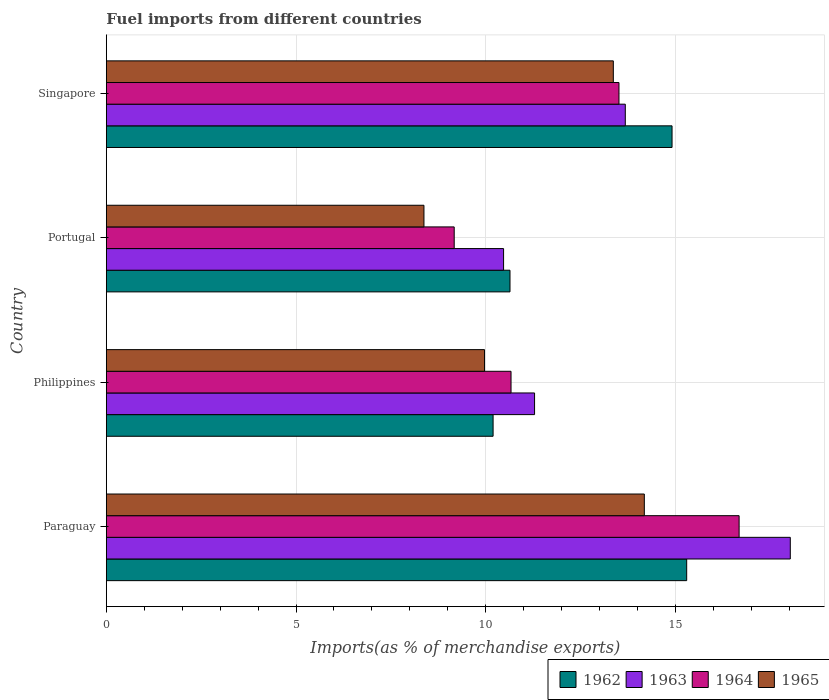How many groups of bars are there?
Provide a short and direct response. 4. Are the number of bars on each tick of the Y-axis equal?
Ensure brevity in your answer.  Yes. How many bars are there on the 1st tick from the bottom?
Keep it short and to the point. 4. What is the label of the 3rd group of bars from the top?
Provide a succinct answer. Philippines. In how many cases, is the number of bars for a given country not equal to the number of legend labels?
Your response must be concise. 0. What is the percentage of imports to different countries in 1962 in Philippines?
Your response must be concise. 10.2. Across all countries, what is the maximum percentage of imports to different countries in 1964?
Provide a succinct answer. 16.68. Across all countries, what is the minimum percentage of imports to different countries in 1965?
Offer a very short reply. 8.37. In which country was the percentage of imports to different countries in 1965 maximum?
Your response must be concise. Paraguay. In which country was the percentage of imports to different countries in 1964 minimum?
Your answer should be compact. Portugal. What is the total percentage of imports to different countries in 1962 in the graph?
Your response must be concise. 51.05. What is the difference between the percentage of imports to different countries in 1964 in Philippines and that in Singapore?
Provide a short and direct response. -2.85. What is the difference between the percentage of imports to different countries in 1963 in Portugal and the percentage of imports to different countries in 1965 in Paraguay?
Offer a very short reply. -3.71. What is the average percentage of imports to different countries in 1963 per country?
Keep it short and to the point. 13.37. What is the difference between the percentage of imports to different countries in 1962 and percentage of imports to different countries in 1965 in Portugal?
Your response must be concise. 2.27. What is the ratio of the percentage of imports to different countries in 1963 in Paraguay to that in Philippines?
Make the answer very short. 1.6. Is the percentage of imports to different countries in 1963 in Paraguay less than that in Philippines?
Ensure brevity in your answer.  No. What is the difference between the highest and the second highest percentage of imports to different countries in 1964?
Make the answer very short. 3.17. What is the difference between the highest and the lowest percentage of imports to different countries in 1963?
Offer a very short reply. 7.56. What does the 4th bar from the top in Philippines represents?
Offer a very short reply. 1962. What does the 4th bar from the bottom in Philippines represents?
Make the answer very short. 1965. Are all the bars in the graph horizontal?
Keep it short and to the point. Yes. Does the graph contain grids?
Make the answer very short. Yes. Where does the legend appear in the graph?
Your answer should be very brief. Bottom right. How many legend labels are there?
Your answer should be compact. 4. What is the title of the graph?
Offer a terse response. Fuel imports from different countries. Does "2006" appear as one of the legend labels in the graph?
Ensure brevity in your answer.  No. What is the label or title of the X-axis?
Your answer should be very brief. Imports(as % of merchandise exports). What is the label or title of the Y-axis?
Your answer should be very brief. Country. What is the Imports(as % of merchandise exports) of 1962 in Paraguay?
Your answer should be very brief. 15.3. What is the Imports(as % of merchandise exports) in 1963 in Paraguay?
Give a very brief answer. 18.03. What is the Imports(as % of merchandise exports) in 1964 in Paraguay?
Provide a succinct answer. 16.68. What is the Imports(as % of merchandise exports) of 1965 in Paraguay?
Your response must be concise. 14.18. What is the Imports(as % of merchandise exports) in 1962 in Philippines?
Your answer should be compact. 10.2. What is the Imports(as % of merchandise exports) of 1963 in Philippines?
Ensure brevity in your answer.  11.29. What is the Imports(as % of merchandise exports) in 1964 in Philippines?
Provide a succinct answer. 10.67. What is the Imports(as % of merchandise exports) of 1965 in Philippines?
Provide a succinct answer. 9.97. What is the Imports(as % of merchandise exports) in 1962 in Portugal?
Keep it short and to the point. 10.64. What is the Imports(as % of merchandise exports) in 1963 in Portugal?
Offer a terse response. 10.47. What is the Imports(as % of merchandise exports) of 1964 in Portugal?
Your answer should be very brief. 9.17. What is the Imports(as % of merchandise exports) of 1965 in Portugal?
Provide a succinct answer. 8.37. What is the Imports(as % of merchandise exports) of 1962 in Singapore?
Keep it short and to the point. 14.91. What is the Imports(as % of merchandise exports) in 1963 in Singapore?
Offer a very short reply. 13.68. What is the Imports(as % of merchandise exports) of 1964 in Singapore?
Offer a terse response. 13.51. What is the Imports(as % of merchandise exports) in 1965 in Singapore?
Offer a terse response. 13.37. Across all countries, what is the maximum Imports(as % of merchandise exports) of 1962?
Your answer should be very brief. 15.3. Across all countries, what is the maximum Imports(as % of merchandise exports) of 1963?
Ensure brevity in your answer.  18.03. Across all countries, what is the maximum Imports(as % of merchandise exports) in 1964?
Your answer should be very brief. 16.68. Across all countries, what is the maximum Imports(as % of merchandise exports) of 1965?
Your answer should be very brief. 14.18. Across all countries, what is the minimum Imports(as % of merchandise exports) in 1962?
Offer a very short reply. 10.2. Across all countries, what is the minimum Imports(as % of merchandise exports) in 1963?
Your response must be concise. 10.47. Across all countries, what is the minimum Imports(as % of merchandise exports) in 1964?
Provide a short and direct response. 9.17. Across all countries, what is the minimum Imports(as % of merchandise exports) of 1965?
Offer a terse response. 8.37. What is the total Imports(as % of merchandise exports) in 1962 in the graph?
Make the answer very short. 51.05. What is the total Imports(as % of merchandise exports) in 1963 in the graph?
Offer a very short reply. 53.47. What is the total Imports(as % of merchandise exports) in 1964 in the graph?
Offer a terse response. 50.03. What is the total Imports(as % of merchandise exports) of 1965 in the graph?
Your answer should be compact. 45.89. What is the difference between the Imports(as % of merchandise exports) in 1962 in Paraguay and that in Philippines?
Offer a terse response. 5.1. What is the difference between the Imports(as % of merchandise exports) in 1963 in Paraguay and that in Philippines?
Make the answer very short. 6.74. What is the difference between the Imports(as % of merchandise exports) of 1964 in Paraguay and that in Philippines?
Ensure brevity in your answer.  6.01. What is the difference between the Imports(as % of merchandise exports) of 1965 in Paraguay and that in Philippines?
Provide a short and direct response. 4.21. What is the difference between the Imports(as % of merchandise exports) of 1962 in Paraguay and that in Portugal?
Offer a very short reply. 4.66. What is the difference between the Imports(as % of merchandise exports) of 1963 in Paraguay and that in Portugal?
Keep it short and to the point. 7.56. What is the difference between the Imports(as % of merchandise exports) of 1964 in Paraguay and that in Portugal?
Offer a terse response. 7.51. What is the difference between the Imports(as % of merchandise exports) of 1965 in Paraguay and that in Portugal?
Provide a succinct answer. 5.81. What is the difference between the Imports(as % of merchandise exports) of 1962 in Paraguay and that in Singapore?
Your answer should be compact. 0.39. What is the difference between the Imports(as % of merchandise exports) in 1963 in Paraguay and that in Singapore?
Keep it short and to the point. 4.35. What is the difference between the Imports(as % of merchandise exports) in 1964 in Paraguay and that in Singapore?
Provide a succinct answer. 3.17. What is the difference between the Imports(as % of merchandise exports) in 1965 in Paraguay and that in Singapore?
Ensure brevity in your answer.  0.82. What is the difference between the Imports(as % of merchandise exports) in 1962 in Philippines and that in Portugal?
Keep it short and to the point. -0.45. What is the difference between the Imports(as % of merchandise exports) of 1963 in Philippines and that in Portugal?
Provide a short and direct response. 0.82. What is the difference between the Imports(as % of merchandise exports) of 1964 in Philippines and that in Portugal?
Offer a very short reply. 1.5. What is the difference between the Imports(as % of merchandise exports) of 1965 in Philippines and that in Portugal?
Ensure brevity in your answer.  1.6. What is the difference between the Imports(as % of merchandise exports) in 1962 in Philippines and that in Singapore?
Your answer should be very brief. -4.72. What is the difference between the Imports(as % of merchandise exports) of 1963 in Philippines and that in Singapore?
Your answer should be compact. -2.39. What is the difference between the Imports(as % of merchandise exports) of 1964 in Philippines and that in Singapore?
Make the answer very short. -2.85. What is the difference between the Imports(as % of merchandise exports) of 1965 in Philippines and that in Singapore?
Offer a very short reply. -3.4. What is the difference between the Imports(as % of merchandise exports) of 1962 in Portugal and that in Singapore?
Your answer should be compact. -4.27. What is the difference between the Imports(as % of merchandise exports) of 1963 in Portugal and that in Singapore?
Your response must be concise. -3.21. What is the difference between the Imports(as % of merchandise exports) of 1964 in Portugal and that in Singapore?
Your answer should be very brief. -4.34. What is the difference between the Imports(as % of merchandise exports) in 1965 in Portugal and that in Singapore?
Provide a short and direct response. -4.99. What is the difference between the Imports(as % of merchandise exports) of 1962 in Paraguay and the Imports(as % of merchandise exports) of 1963 in Philippines?
Your response must be concise. 4.01. What is the difference between the Imports(as % of merchandise exports) of 1962 in Paraguay and the Imports(as % of merchandise exports) of 1964 in Philippines?
Keep it short and to the point. 4.63. What is the difference between the Imports(as % of merchandise exports) in 1962 in Paraguay and the Imports(as % of merchandise exports) in 1965 in Philippines?
Your answer should be very brief. 5.33. What is the difference between the Imports(as % of merchandise exports) of 1963 in Paraguay and the Imports(as % of merchandise exports) of 1964 in Philippines?
Your answer should be compact. 7.36. What is the difference between the Imports(as % of merchandise exports) in 1963 in Paraguay and the Imports(as % of merchandise exports) in 1965 in Philippines?
Ensure brevity in your answer.  8.06. What is the difference between the Imports(as % of merchandise exports) in 1964 in Paraguay and the Imports(as % of merchandise exports) in 1965 in Philippines?
Provide a short and direct response. 6.71. What is the difference between the Imports(as % of merchandise exports) of 1962 in Paraguay and the Imports(as % of merchandise exports) of 1963 in Portugal?
Offer a very short reply. 4.83. What is the difference between the Imports(as % of merchandise exports) of 1962 in Paraguay and the Imports(as % of merchandise exports) of 1964 in Portugal?
Offer a very short reply. 6.13. What is the difference between the Imports(as % of merchandise exports) of 1962 in Paraguay and the Imports(as % of merchandise exports) of 1965 in Portugal?
Offer a terse response. 6.93. What is the difference between the Imports(as % of merchandise exports) of 1963 in Paraguay and the Imports(as % of merchandise exports) of 1964 in Portugal?
Your answer should be compact. 8.86. What is the difference between the Imports(as % of merchandise exports) in 1963 in Paraguay and the Imports(as % of merchandise exports) in 1965 in Portugal?
Ensure brevity in your answer.  9.66. What is the difference between the Imports(as % of merchandise exports) in 1964 in Paraguay and the Imports(as % of merchandise exports) in 1965 in Portugal?
Provide a succinct answer. 8.31. What is the difference between the Imports(as % of merchandise exports) of 1962 in Paraguay and the Imports(as % of merchandise exports) of 1963 in Singapore?
Give a very brief answer. 1.62. What is the difference between the Imports(as % of merchandise exports) in 1962 in Paraguay and the Imports(as % of merchandise exports) in 1964 in Singapore?
Ensure brevity in your answer.  1.79. What is the difference between the Imports(as % of merchandise exports) of 1962 in Paraguay and the Imports(as % of merchandise exports) of 1965 in Singapore?
Give a very brief answer. 1.93. What is the difference between the Imports(as % of merchandise exports) in 1963 in Paraguay and the Imports(as % of merchandise exports) in 1964 in Singapore?
Provide a succinct answer. 4.52. What is the difference between the Imports(as % of merchandise exports) in 1963 in Paraguay and the Imports(as % of merchandise exports) in 1965 in Singapore?
Provide a short and direct response. 4.67. What is the difference between the Imports(as % of merchandise exports) in 1964 in Paraguay and the Imports(as % of merchandise exports) in 1965 in Singapore?
Your answer should be very brief. 3.32. What is the difference between the Imports(as % of merchandise exports) in 1962 in Philippines and the Imports(as % of merchandise exports) in 1963 in Portugal?
Your response must be concise. -0.28. What is the difference between the Imports(as % of merchandise exports) of 1962 in Philippines and the Imports(as % of merchandise exports) of 1964 in Portugal?
Give a very brief answer. 1.03. What is the difference between the Imports(as % of merchandise exports) in 1962 in Philippines and the Imports(as % of merchandise exports) in 1965 in Portugal?
Ensure brevity in your answer.  1.82. What is the difference between the Imports(as % of merchandise exports) of 1963 in Philippines and the Imports(as % of merchandise exports) of 1964 in Portugal?
Offer a terse response. 2.12. What is the difference between the Imports(as % of merchandise exports) of 1963 in Philippines and the Imports(as % of merchandise exports) of 1965 in Portugal?
Offer a terse response. 2.92. What is the difference between the Imports(as % of merchandise exports) of 1964 in Philippines and the Imports(as % of merchandise exports) of 1965 in Portugal?
Keep it short and to the point. 2.3. What is the difference between the Imports(as % of merchandise exports) of 1962 in Philippines and the Imports(as % of merchandise exports) of 1963 in Singapore?
Offer a very short reply. -3.49. What is the difference between the Imports(as % of merchandise exports) in 1962 in Philippines and the Imports(as % of merchandise exports) in 1964 in Singapore?
Ensure brevity in your answer.  -3.32. What is the difference between the Imports(as % of merchandise exports) in 1962 in Philippines and the Imports(as % of merchandise exports) in 1965 in Singapore?
Provide a succinct answer. -3.17. What is the difference between the Imports(as % of merchandise exports) of 1963 in Philippines and the Imports(as % of merchandise exports) of 1964 in Singapore?
Provide a succinct answer. -2.23. What is the difference between the Imports(as % of merchandise exports) of 1963 in Philippines and the Imports(as % of merchandise exports) of 1965 in Singapore?
Provide a succinct answer. -2.08. What is the difference between the Imports(as % of merchandise exports) of 1964 in Philippines and the Imports(as % of merchandise exports) of 1965 in Singapore?
Keep it short and to the point. -2.7. What is the difference between the Imports(as % of merchandise exports) in 1962 in Portugal and the Imports(as % of merchandise exports) in 1963 in Singapore?
Offer a very short reply. -3.04. What is the difference between the Imports(as % of merchandise exports) in 1962 in Portugal and the Imports(as % of merchandise exports) in 1964 in Singapore?
Provide a short and direct response. -2.87. What is the difference between the Imports(as % of merchandise exports) of 1962 in Portugal and the Imports(as % of merchandise exports) of 1965 in Singapore?
Give a very brief answer. -2.72. What is the difference between the Imports(as % of merchandise exports) of 1963 in Portugal and the Imports(as % of merchandise exports) of 1964 in Singapore?
Provide a short and direct response. -3.04. What is the difference between the Imports(as % of merchandise exports) of 1963 in Portugal and the Imports(as % of merchandise exports) of 1965 in Singapore?
Your answer should be compact. -2.89. What is the difference between the Imports(as % of merchandise exports) of 1964 in Portugal and the Imports(as % of merchandise exports) of 1965 in Singapore?
Offer a very short reply. -4.19. What is the average Imports(as % of merchandise exports) in 1962 per country?
Your response must be concise. 12.76. What is the average Imports(as % of merchandise exports) in 1963 per country?
Give a very brief answer. 13.37. What is the average Imports(as % of merchandise exports) in 1964 per country?
Your answer should be compact. 12.51. What is the average Imports(as % of merchandise exports) of 1965 per country?
Your response must be concise. 11.47. What is the difference between the Imports(as % of merchandise exports) of 1962 and Imports(as % of merchandise exports) of 1963 in Paraguay?
Your response must be concise. -2.73. What is the difference between the Imports(as % of merchandise exports) of 1962 and Imports(as % of merchandise exports) of 1964 in Paraguay?
Your answer should be compact. -1.38. What is the difference between the Imports(as % of merchandise exports) of 1962 and Imports(as % of merchandise exports) of 1965 in Paraguay?
Offer a very short reply. 1.12. What is the difference between the Imports(as % of merchandise exports) of 1963 and Imports(as % of merchandise exports) of 1964 in Paraguay?
Your answer should be compact. 1.35. What is the difference between the Imports(as % of merchandise exports) in 1963 and Imports(as % of merchandise exports) in 1965 in Paraguay?
Your answer should be very brief. 3.85. What is the difference between the Imports(as % of merchandise exports) of 1964 and Imports(as % of merchandise exports) of 1965 in Paraguay?
Keep it short and to the point. 2.5. What is the difference between the Imports(as % of merchandise exports) of 1962 and Imports(as % of merchandise exports) of 1963 in Philippines?
Provide a short and direct response. -1.09. What is the difference between the Imports(as % of merchandise exports) in 1962 and Imports(as % of merchandise exports) in 1964 in Philippines?
Ensure brevity in your answer.  -0.47. What is the difference between the Imports(as % of merchandise exports) of 1962 and Imports(as % of merchandise exports) of 1965 in Philippines?
Ensure brevity in your answer.  0.23. What is the difference between the Imports(as % of merchandise exports) of 1963 and Imports(as % of merchandise exports) of 1964 in Philippines?
Provide a short and direct response. 0.62. What is the difference between the Imports(as % of merchandise exports) of 1963 and Imports(as % of merchandise exports) of 1965 in Philippines?
Offer a very short reply. 1.32. What is the difference between the Imports(as % of merchandise exports) in 1964 and Imports(as % of merchandise exports) in 1965 in Philippines?
Your response must be concise. 0.7. What is the difference between the Imports(as % of merchandise exports) of 1962 and Imports(as % of merchandise exports) of 1963 in Portugal?
Offer a terse response. 0.17. What is the difference between the Imports(as % of merchandise exports) of 1962 and Imports(as % of merchandise exports) of 1964 in Portugal?
Provide a short and direct response. 1.47. What is the difference between the Imports(as % of merchandise exports) of 1962 and Imports(as % of merchandise exports) of 1965 in Portugal?
Provide a short and direct response. 2.27. What is the difference between the Imports(as % of merchandise exports) of 1963 and Imports(as % of merchandise exports) of 1964 in Portugal?
Give a very brief answer. 1.3. What is the difference between the Imports(as % of merchandise exports) of 1963 and Imports(as % of merchandise exports) of 1965 in Portugal?
Ensure brevity in your answer.  2.1. What is the difference between the Imports(as % of merchandise exports) in 1964 and Imports(as % of merchandise exports) in 1965 in Portugal?
Offer a very short reply. 0.8. What is the difference between the Imports(as % of merchandise exports) of 1962 and Imports(as % of merchandise exports) of 1963 in Singapore?
Make the answer very short. 1.23. What is the difference between the Imports(as % of merchandise exports) of 1962 and Imports(as % of merchandise exports) of 1964 in Singapore?
Your response must be concise. 1.4. What is the difference between the Imports(as % of merchandise exports) in 1962 and Imports(as % of merchandise exports) in 1965 in Singapore?
Ensure brevity in your answer.  1.55. What is the difference between the Imports(as % of merchandise exports) of 1963 and Imports(as % of merchandise exports) of 1964 in Singapore?
Give a very brief answer. 0.17. What is the difference between the Imports(as % of merchandise exports) in 1963 and Imports(as % of merchandise exports) in 1965 in Singapore?
Make the answer very short. 0.32. What is the difference between the Imports(as % of merchandise exports) of 1964 and Imports(as % of merchandise exports) of 1965 in Singapore?
Your response must be concise. 0.15. What is the ratio of the Imports(as % of merchandise exports) of 1962 in Paraguay to that in Philippines?
Offer a terse response. 1.5. What is the ratio of the Imports(as % of merchandise exports) of 1963 in Paraguay to that in Philippines?
Your response must be concise. 1.6. What is the ratio of the Imports(as % of merchandise exports) of 1964 in Paraguay to that in Philippines?
Make the answer very short. 1.56. What is the ratio of the Imports(as % of merchandise exports) in 1965 in Paraguay to that in Philippines?
Give a very brief answer. 1.42. What is the ratio of the Imports(as % of merchandise exports) of 1962 in Paraguay to that in Portugal?
Make the answer very short. 1.44. What is the ratio of the Imports(as % of merchandise exports) in 1963 in Paraguay to that in Portugal?
Ensure brevity in your answer.  1.72. What is the ratio of the Imports(as % of merchandise exports) in 1964 in Paraguay to that in Portugal?
Provide a succinct answer. 1.82. What is the ratio of the Imports(as % of merchandise exports) of 1965 in Paraguay to that in Portugal?
Give a very brief answer. 1.69. What is the ratio of the Imports(as % of merchandise exports) of 1962 in Paraguay to that in Singapore?
Offer a terse response. 1.03. What is the ratio of the Imports(as % of merchandise exports) in 1963 in Paraguay to that in Singapore?
Offer a very short reply. 1.32. What is the ratio of the Imports(as % of merchandise exports) of 1964 in Paraguay to that in Singapore?
Make the answer very short. 1.23. What is the ratio of the Imports(as % of merchandise exports) of 1965 in Paraguay to that in Singapore?
Provide a succinct answer. 1.06. What is the ratio of the Imports(as % of merchandise exports) in 1962 in Philippines to that in Portugal?
Provide a succinct answer. 0.96. What is the ratio of the Imports(as % of merchandise exports) in 1963 in Philippines to that in Portugal?
Your answer should be very brief. 1.08. What is the ratio of the Imports(as % of merchandise exports) of 1964 in Philippines to that in Portugal?
Ensure brevity in your answer.  1.16. What is the ratio of the Imports(as % of merchandise exports) of 1965 in Philippines to that in Portugal?
Keep it short and to the point. 1.19. What is the ratio of the Imports(as % of merchandise exports) of 1962 in Philippines to that in Singapore?
Offer a very short reply. 0.68. What is the ratio of the Imports(as % of merchandise exports) of 1963 in Philippines to that in Singapore?
Your response must be concise. 0.83. What is the ratio of the Imports(as % of merchandise exports) in 1964 in Philippines to that in Singapore?
Your answer should be very brief. 0.79. What is the ratio of the Imports(as % of merchandise exports) in 1965 in Philippines to that in Singapore?
Your answer should be very brief. 0.75. What is the ratio of the Imports(as % of merchandise exports) of 1962 in Portugal to that in Singapore?
Ensure brevity in your answer.  0.71. What is the ratio of the Imports(as % of merchandise exports) of 1963 in Portugal to that in Singapore?
Offer a very short reply. 0.77. What is the ratio of the Imports(as % of merchandise exports) in 1964 in Portugal to that in Singapore?
Keep it short and to the point. 0.68. What is the ratio of the Imports(as % of merchandise exports) in 1965 in Portugal to that in Singapore?
Your answer should be very brief. 0.63. What is the difference between the highest and the second highest Imports(as % of merchandise exports) in 1962?
Offer a very short reply. 0.39. What is the difference between the highest and the second highest Imports(as % of merchandise exports) in 1963?
Your response must be concise. 4.35. What is the difference between the highest and the second highest Imports(as % of merchandise exports) in 1964?
Your answer should be very brief. 3.17. What is the difference between the highest and the second highest Imports(as % of merchandise exports) of 1965?
Provide a short and direct response. 0.82. What is the difference between the highest and the lowest Imports(as % of merchandise exports) of 1962?
Your answer should be compact. 5.1. What is the difference between the highest and the lowest Imports(as % of merchandise exports) in 1963?
Provide a short and direct response. 7.56. What is the difference between the highest and the lowest Imports(as % of merchandise exports) in 1964?
Offer a very short reply. 7.51. What is the difference between the highest and the lowest Imports(as % of merchandise exports) of 1965?
Your answer should be very brief. 5.81. 